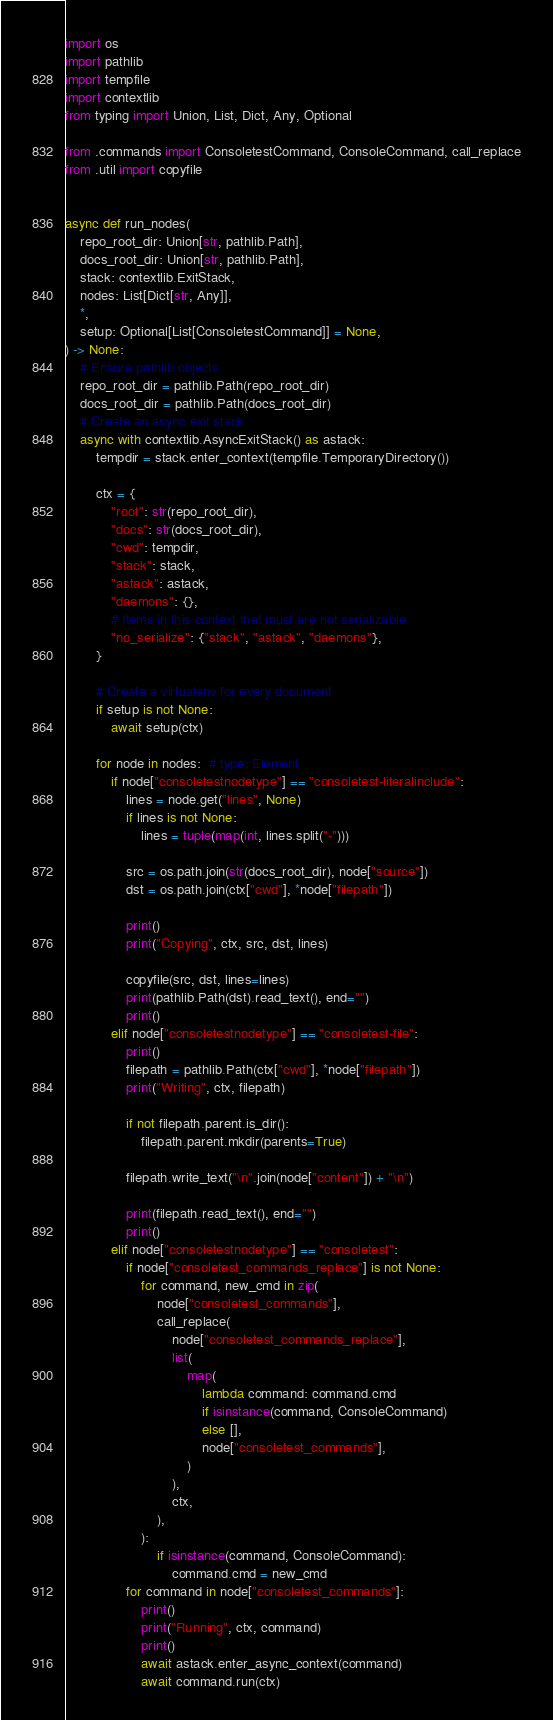<code> <loc_0><loc_0><loc_500><loc_500><_Python_>import os
import pathlib
import tempfile
import contextlib
from typing import Union, List, Dict, Any, Optional

from .commands import ConsoletestCommand, ConsoleCommand, call_replace
from .util import copyfile


async def run_nodes(
    repo_root_dir: Union[str, pathlib.Path],
    docs_root_dir: Union[str, pathlib.Path],
    stack: contextlib.ExitStack,
    nodes: List[Dict[str, Any]],
    *,
    setup: Optional[List[ConsoletestCommand]] = None,
) -> None:
    # Ensure pathlib objects
    repo_root_dir = pathlib.Path(repo_root_dir)
    docs_root_dir = pathlib.Path(docs_root_dir)
    # Create an async exit stack
    async with contextlib.AsyncExitStack() as astack:
        tempdir = stack.enter_context(tempfile.TemporaryDirectory())

        ctx = {
            "root": str(repo_root_dir),
            "docs": str(docs_root_dir),
            "cwd": tempdir,
            "stack": stack,
            "astack": astack,
            "daemons": {},
            # Items in this context that must are not serializable
            "no_serialize": {"stack", "astack", "daemons"},
        }

        # Create a virtualenv for every document
        if setup is not None:
            await setup(ctx)

        for node in nodes:  # type: Element
            if node["consoletestnodetype"] == "consoletest-literalinclude":
                lines = node.get("lines", None)
                if lines is not None:
                    lines = tuple(map(int, lines.split("-")))

                src = os.path.join(str(docs_root_dir), node["source"])
                dst = os.path.join(ctx["cwd"], *node["filepath"])

                print()
                print("Copying", ctx, src, dst, lines)

                copyfile(src, dst, lines=lines)
                print(pathlib.Path(dst).read_text(), end="")
                print()
            elif node["consoletestnodetype"] == "consoletest-file":
                print()
                filepath = pathlib.Path(ctx["cwd"], *node["filepath"])
                print("Writing", ctx, filepath)

                if not filepath.parent.is_dir():
                    filepath.parent.mkdir(parents=True)

                filepath.write_text("\n".join(node["content"]) + "\n")

                print(filepath.read_text(), end="")
                print()
            elif node["consoletestnodetype"] == "consoletest":
                if node["consoletest_commands_replace"] is not None:
                    for command, new_cmd in zip(
                        node["consoletest_commands"],
                        call_replace(
                            node["consoletest_commands_replace"],
                            list(
                                map(
                                    lambda command: command.cmd
                                    if isinstance(command, ConsoleCommand)
                                    else [],
                                    node["consoletest_commands"],
                                )
                            ),
                            ctx,
                        ),
                    ):
                        if isinstance(command, ConsoleCommand):
                            command.cmd = new_cmd
                for command in node["consoletest_commands"]:
                    print()
                    print("Running", ctx, command)
                    print()
                    await astack.enter_async_context(command)
                    await command.run(ctx)
</code> 